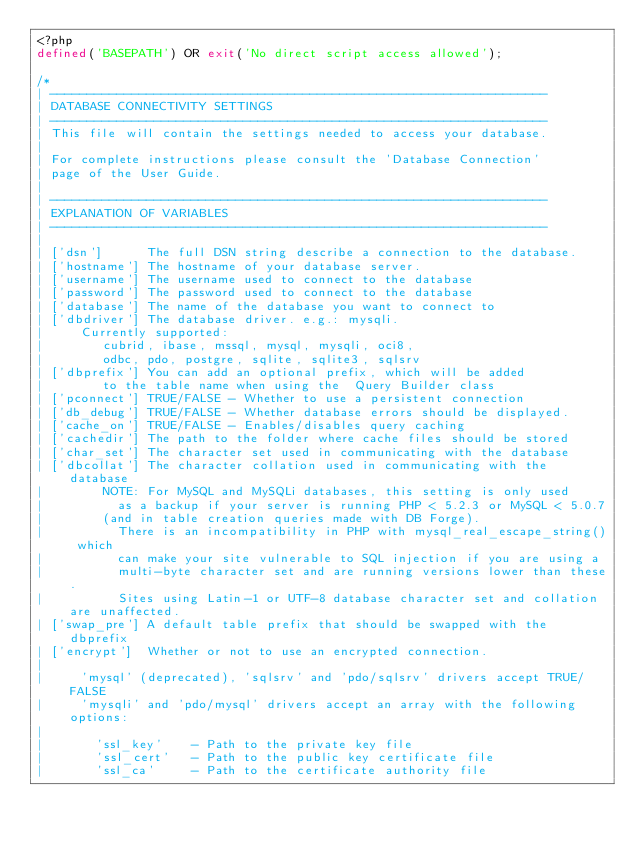<code> <loc_0><loc_0><loc_500><loc_500><_PHP_><?php
defined('BASEPATH') OR exit('No direct script access allowed');

/*
| -------------------------------------------------------------------
| DATABASE CONNECTIVITY SETTINGS
| -------------------------------------------------------------------
| This file will contain the settings needed to access your database.
|
| For complete instructions please consult the 'Database Connection'
| page of the User Guide.
|
| -------------------------------------------------------------------
| EXPLANATION OF VARIABLES
| -------------------------------------------------------------------
|
|	['dsn']      The full DSN string describe a connection to the database.
|	['hostname'] The hostname of your database server.
|	['username'] The username used to connect to the database
|	['password'] The password used to connect to the database
|	['database'] The name of the database you want to connect to
|	['dbdriver'] The database driver. e.g.: mysqli.
|			Currently supported:
|				 cubrid, ibase, mssql, mysql, mysqli, oci8,
|				 odbc, pdo, postgre, sqlite, sqlite3, sqlsrv
|	['dbprefix'] You can add an optional prefix, which will be added
|				 to the table name when using the  Query Builder class
|	['pconnect'] TRUE/FALSE - Whether to use a persistent connection
|	['db_debug'] TRUE/FALSE - Whether database errors should be displayed.
|	['cache_on'] TRUE/FALSE - Enables/disables query caching
|	['cachedir'] The path to the folder where cache files should be stored
|	['char_set'] The character set used in communicating with the database
|	['dbcollat'] The character collation used in communicating with the database
|				 NOTE: For MySQL and MySQLi databases, this setting is only used
| 				 as a backup if your server is running PHP < 5.2.3 or MySQL < 5.0.7
|				 (and in table creation queries made with DB Forge).
| 				 There is an incompatibility in PHP with mysql_real_escape_string() which
| 				 can make your site vulnerable to SQL injection if you are using a
| 				 multi-byte character set and are running versions lower than these.
| 				 Sites using Latin-1 or UTF-8 database character set and collation are unaffected.
|	['swap_pre'] A default table prefix that should be swapped with the dbprefix
|	['encrypt']  Whether or not to use an encrypted connection.
|
|			'mysql' (deprecated), 'sqlsrv' and 'pdo/sqlsrv' drivers accept TRUE/FALSE
|			'mysqli' and 'pdo/mysql' drivers accept an array with the following options:
|
|				'ssl_key'    - Path to the private key file
|				'ssl_cert'   - Path to the public key certificate file
|				'ssl_ca'     - Path to the certificate authority file</code> 